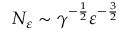<formula> <loc_0><loc_0><loc_500><loc_500>N _ { \varepsilon } \sim \gamma ^ { - \frac { 1 } { 2 } } \varepsilon ^ { - \frac { 3 } { 2 } }</formula> 